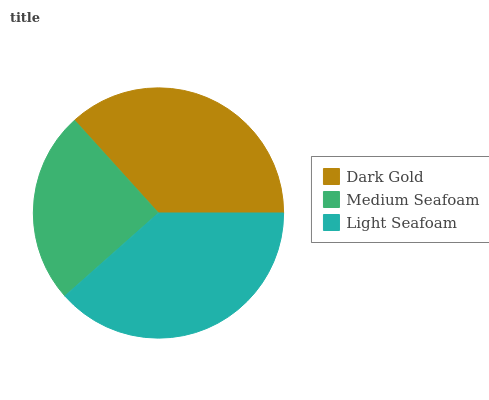Is Medium Seafoam the minimum?
Answer yes or no. Yes. Is Light Seafoam the maximum?
Answer yes or no. Yes. Is Light Seafoam the minimum?
Answer yes or no. No. Is Medium Seafoam the maximum?
Answer yes or no. No. Is Light Seafoam greater than Medium Seafoam?
Answer yes or no. Yes. Is Medium Seafoam less than Light Seafoam?
Answer yes or no. Yes. Is Medium Seafoam greater than Light Seafoam?
Answer yes or no. No. Is Light Seafoam less than Medium Seafoam?
Answer yes or no. No. Is Dark Gold the high median?
Answer yes or no. Yes. Is Dark Gold the low median?
Answer yes or no. Yes. Is Medium Seafoam the high median?
Answer yes or no. No. Is Light Seafoam the low median?
Answer yes or no. No. 